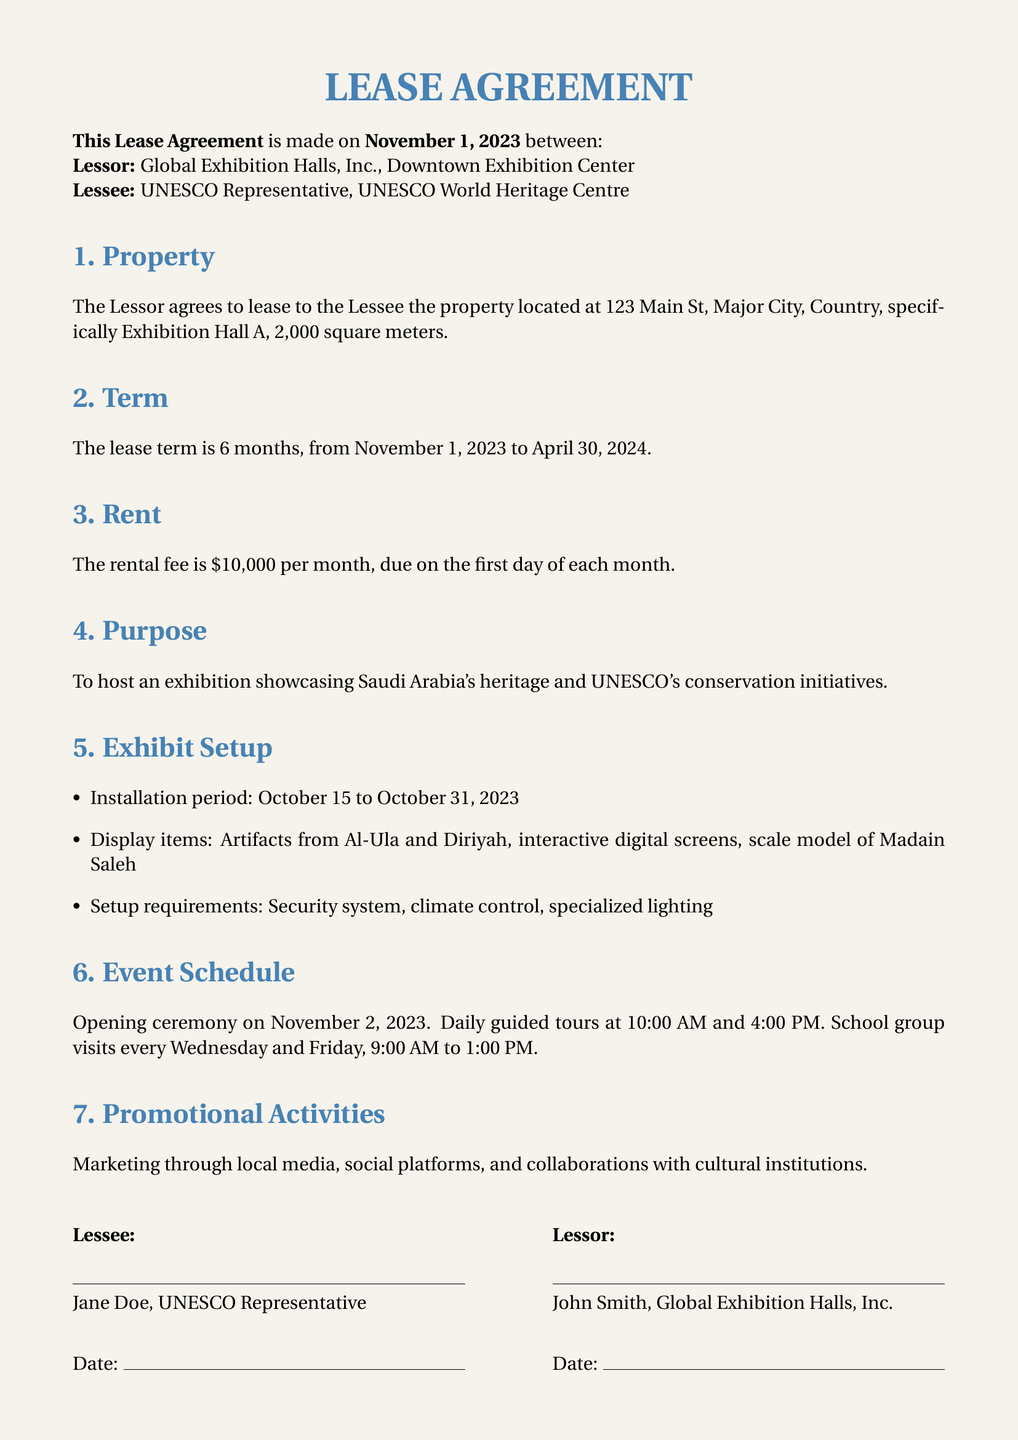What is the address of the property? The address of the property is specified in the document as 123 Main St, Major City, Country.
Answer: 123 Main St, Major City, Country What is the duration of the lease? The document states the lease term is from November 1, 2023, to April 30, 2024, which indicates a duration of 6 months.
Answer: 6 months How much is the monthly rental fee? The rental fee per month is listed directly in the document as $10,000.
Answer: $10,000 What is one of the display items in the exhibition? The document lists multiple display items including artifacts from Al-Ula, which is one example of a display item.
Answer: Artifacts from Al-Ula When is the opening ceremony scheduled? The document specifies that the opening ceremony will take place on November 2, 2023.
Answer: November 2, 2023 How many guided tours are scheduled daily? According to the event schedule in the document, there are two guided tours scheduled daily, at 10:00 AM and 4:00 PM.
Answer: Two What marketing channels will be used? The document mentions that marketing will occur through local media, social platforms, and collaborations with cultural institutions as part of promotional activities.
Answer: Local media, social platforms, collaborations with cultural institutions Who is the lessee? The lessee is identified in the document as the UNESCO Representative, specifically Jane Doe.
Answer: Jane Doe What is the installation period for the exhibit setup? The document outlines that the installation period is from October 15 to October 31, 2023.
Answer: October 15 to October 31, 2023 